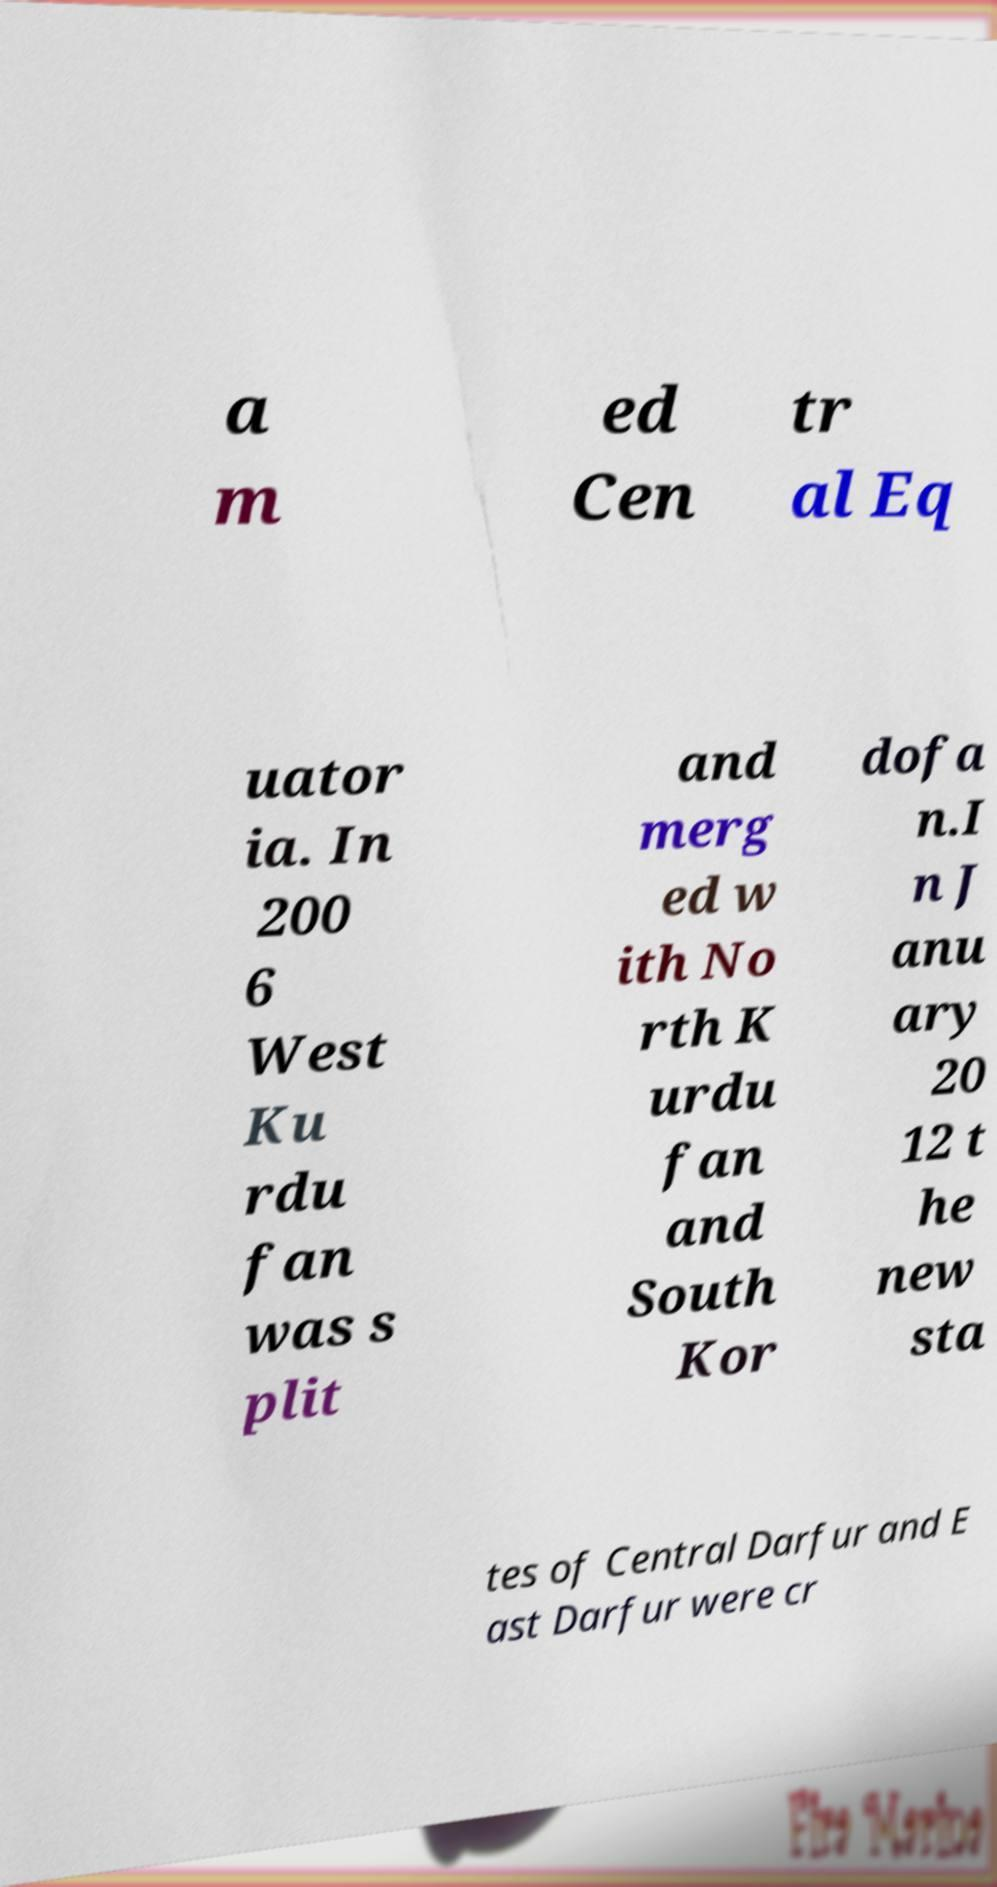Please identify and transcribe the text found in this image. a m ed Cen tr al Eq uator ia. In 200 6 West Ku rdu fan was s plit and merg ed w ith No rth K urdu fan and South Kor dofa n.I n J anu ary 20 12 t he new sta tes of Central Darfur and E ast Darfur were cr 